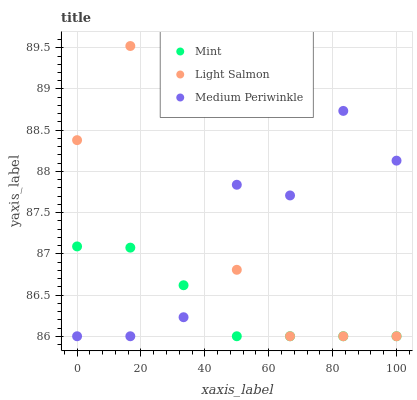Does Mint have the minimum area under the curve?
Answer yes or no. Yes. Does Light Salmon have the maximum area under the curve?
Answer yes or no. Yes. Does Light Salmon have the minimum area under the curve?
Answer yes or no. No. Does Mint have the maximum area under the curve?
Answer yes or no. No. Is Mint the smoothest?
Answer yes or no. Yes. Is Medium Periwinkle the roughest?
Answer yes or no. Yes. Is Light Salmon the smoothest?
Answer yes or no. No. Is Light Salmon the roughest?
Answer yes or no. No. Does Medium Periwinkle have the lowest value?
Answer yes or no. Yes. Does Light Salmon have the highest value?
Answer yes or no. Yes. Does Mint have the highest value?
Answer yes or no. No. Does Medium Periwinkle intersect Mint?
Answer yes or no. Yes. Is Medium Periwinkle less than Mint?
Answer yes or no. No. Is Medium Periwinkle greater than Mint?
Answer yes or no. No. 